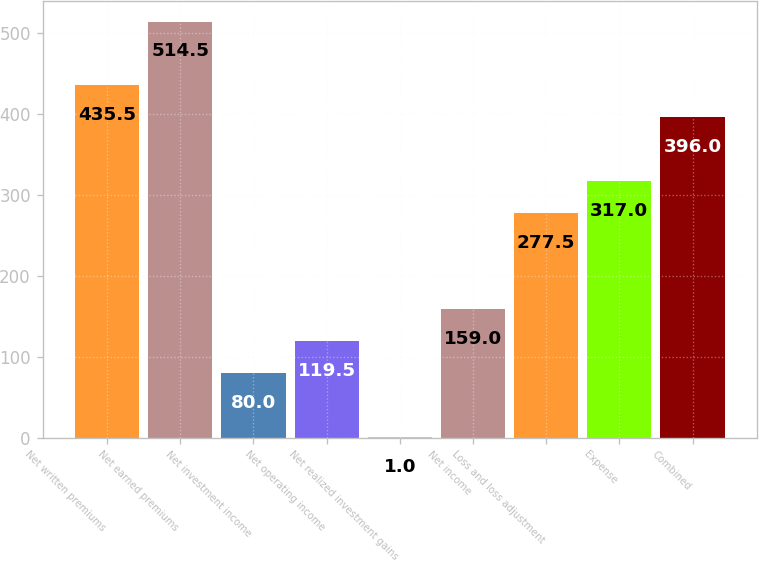<chart> <loc_0><loc_0><loc_500><loc_500><bar_chart><fcel>Net written premiums<fcel>Net earned premiums<fcel>Net investment income<fcel>Net operating income<fcel>Net realized investment gains<fcel>Net income<fcel>Loss and loss adjustment<fcel>Expense<fcel>Combined<nl><fcel>435.5<fcel>514.5<fcel>80<fcel>119.5<fcel>1<fcel>159<fcel>277.5<fcel>317<fcel>396<nl></chart> 